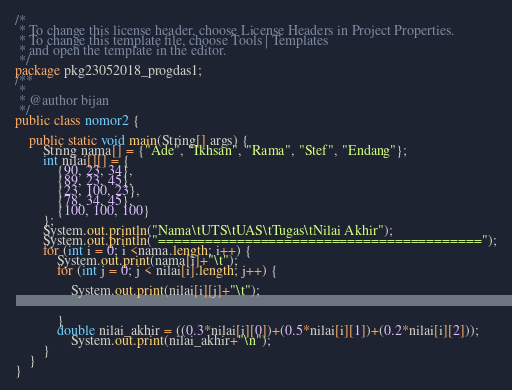Convert code to text. <code><loc_0><loc_0><loc_500><loc_500><_Java_>/*
 * To change this license header, choose License Headers in Project Properties.
 * To change this template file, choose Tools | Templates
 * and open the template in the editor.
 */
package pkg23052018_progdas1;
/**
 *
 * @author bijan
 */
public class nomor2 {

    public static void main(String[] args) {
        String nama[] = {"Ade", "Ikhsan", "Rama", "Stef", "Endang"};
        int nilai[][] = {
            {90, 23, 34},
            {89, 23, 45},
            {23, 100, 23},
            {78, 34, 45},
            {100, 100, 100}
        };
        System.out.println("Nama\tUTS\tUAS\tTugas\tNilai Akhir");
        System.out.println("=========================================");
        for (int i = 0; i <nama.length; i++) {
            System.out.print(nama[i]+"\t");
            for (int j = 0; j < nilai[i].length; j++) {
                
                System.out.print(nilai[i][j]+"\t");
                
                
            }
            double nilai_akhir = ((0.3*nilai[i][0])+(0.5*nilai[i][1])+(0.2*nilai[i][2]));
                System.out.print(nilai_akhir+"\n");
        }
    }
}
</code> 